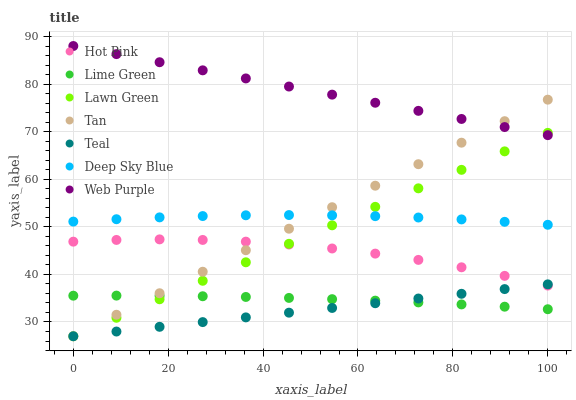Does Teal have the minimum area under the curve?
Answer yes or no. Yes. Does Web Purple have the maximum area under the curve?
Answer yes or no. Yes. Does Hot Pink have the minimum area under the curve?
Answer yes or no. No. Does Hot Pink have the maximum area under the curve?
Answer yes or no. No. Is Teal the smoothest?
Answer yes or no. Yes. Is Hot Pink the roughest?
Answer yes or no. Yes. Is Hot Pink the smoothest?
Answer yes or no. No. Is Teal the roughest?
Answer yes or no. No. Does Lawn Green have the lowest value?
Answer yes or no. Yes. Does Hot Pink have the lowest value?
Answer yes or no. No. Does Web Purple have the highest value?
Answer yes or no. Yes. Does Teal have the highest value?
Answer yes or no. No. Is Deep Sky Blue less than Web Purple?
Answer yes or no. Yes. Is Web Purple greater than Deep Sky Blue?
Answer yes or no. Yes. Does Web Purple intersect Tan?
Answer yes or no. Yes. Is Web Purple less than Tan?
Answer yes or no. No. Is Web Purple greater than Tan?
Answer yes or no. No. Does Deep Sky Blue intersect Web Purple?
Answer yes or no. No. 